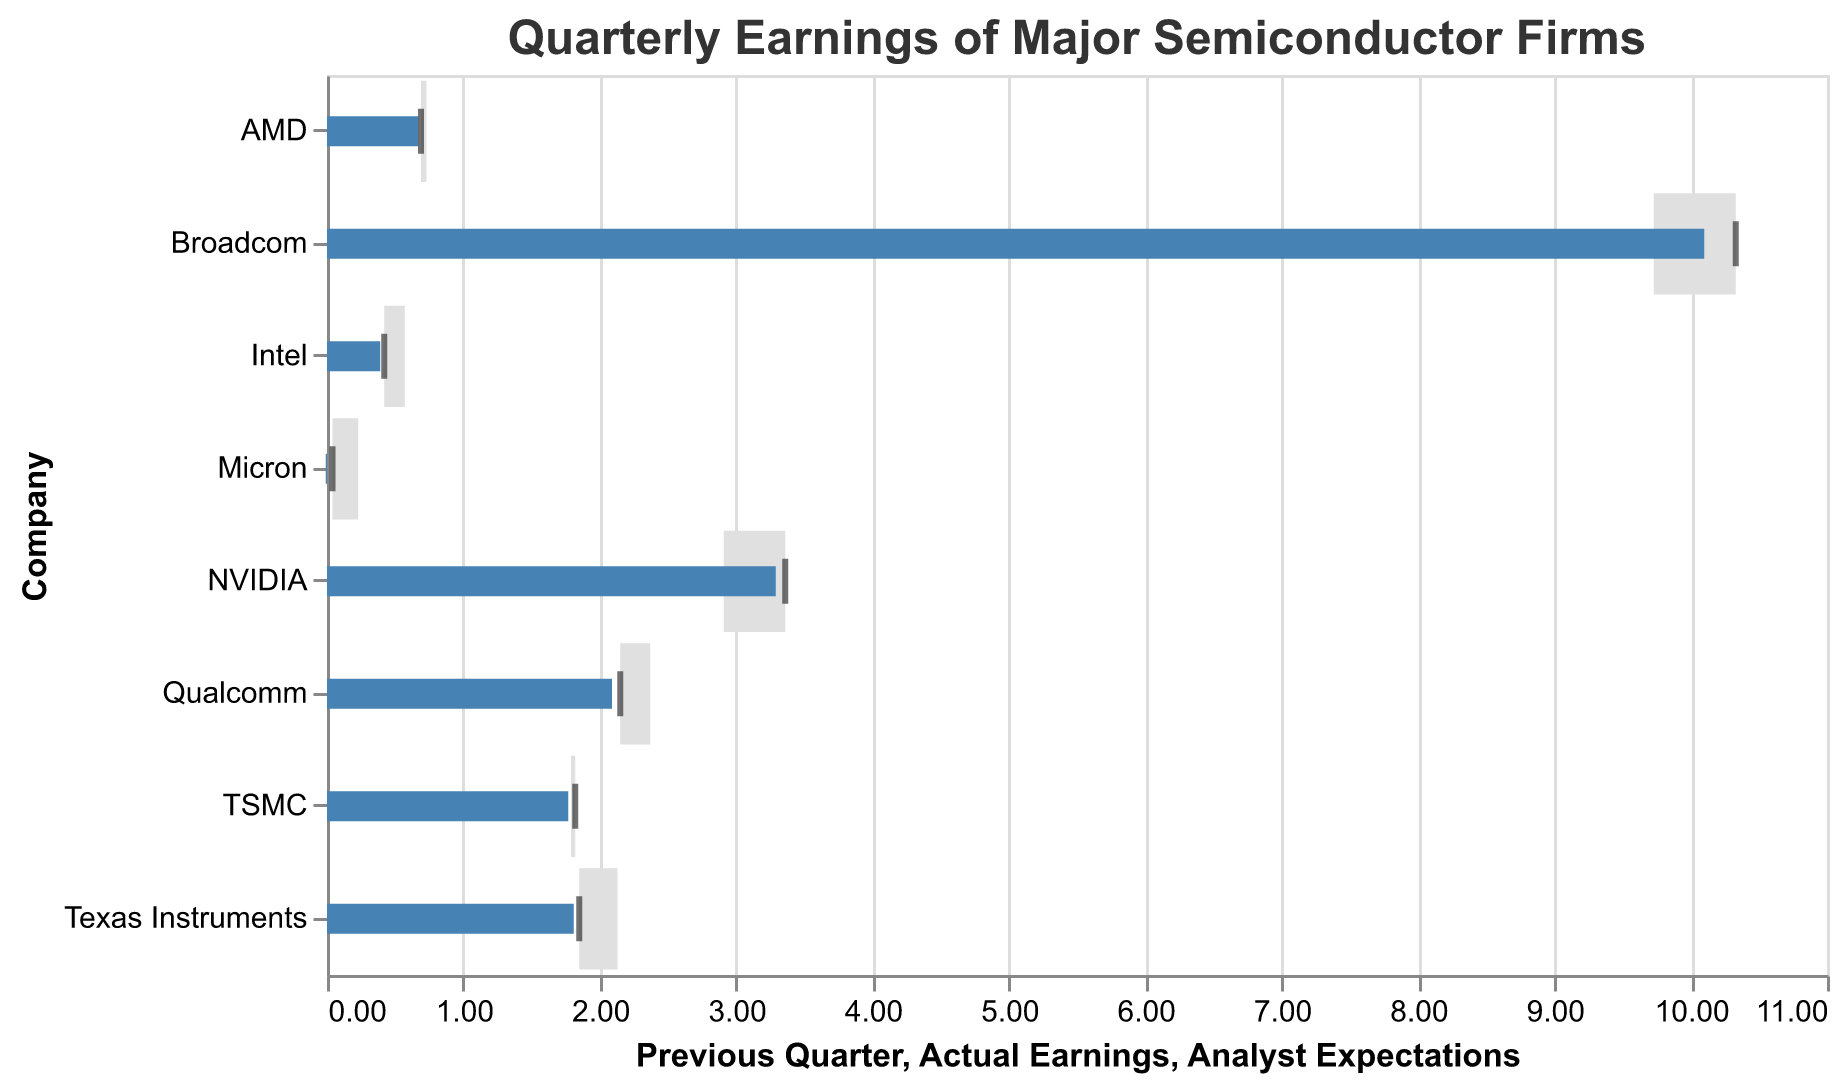What's the title of the figure? The figure's title is displayed at the top in the configuration of the chart. It is "Quarterly Earnings of Major Semiconductor Firms".
Answer: Quarterly Earnings of Major Semiconductor Firms Which company has the highest Actual Earnings? The Actual Earnings can be identified by the tick mark's position on the x-axis. Broadcom has the highest tick mark value which is 10.33.
Answer: Broadcom Which company's Actual Earnings were closest to Analyst Expectations? By comparing the tick mark (Actual Earnings) and the blue bar (Analyst Expectations), we see that NVIDIA's actual earnings of 3.36 are the closest to the analyst expectations of 3.29.
Answer: NVIDIA For which company the Actual Earnings were higher than the Previous Quarter but lower than Analyst Expectations? The Actual Earnings tick marks must be higher than grey bars (Previous Quarter) and lower than blue bars (Analyst Expectations). For Intel, Actual Earnings (0.42) are higher than Previous Quarter (0.57) but lower than Analyst Expectations (0.39).
Answer: Intel What is the range of Actual Earnings for the companies? The lower boundary of the Actual Earnings range is determined by the lowest tick mark, and the upper boundary is the highest tick mark. The range is from Micron's 0.04 to Broadcom's 10.33.
Answer: 0.04 to 10.33 List the companies that exceeded Analyst Expectations in Actual Earnings. The companies where the Actual Earnings tick mark is further to the right compared to the blue bar (Analyst Expectations) are NVIDIA, Intel, AMD, TSMC, Qualcomm, Broadcom, Micron, and Texas Instruments.
Answer: NVIDIA, Intel, AMD, TSMC, Qualcomm, Broadcom, Micron, Texas Instruments Which company had the most significant decrease in Actual Earnings compared to the Previous Quarter? The difference can be checked by noting the length of the grey bar compared to the tick mark. For Qualcomm, the decrease from 2.37 (Previous Quarter) to 2.15 (Actual Earnings) is the most significant drop.
Answer: Qualcomm What is the average Actual Earnings of all the companies listed? Add all the companies' Actual Earnings and divide by the number of companies. (3.36 + 0.42 + 0.69 + 1.82 + 2.15 + 10.33 + 0.04 + 1.85) / 8 = 2.83
Answer: 2.83 How does Texas Instruments' Actual Earnings compare to its Analyst Expectations and Previous Quarter? Texas Instruments' Actual Earnings (1.85) surpasses Analyst Expectations (1.81) but are lower than its Previous Quarter (2.13).
Answer: Surpasses Analyst Expectations but lower than Previous Quarter 